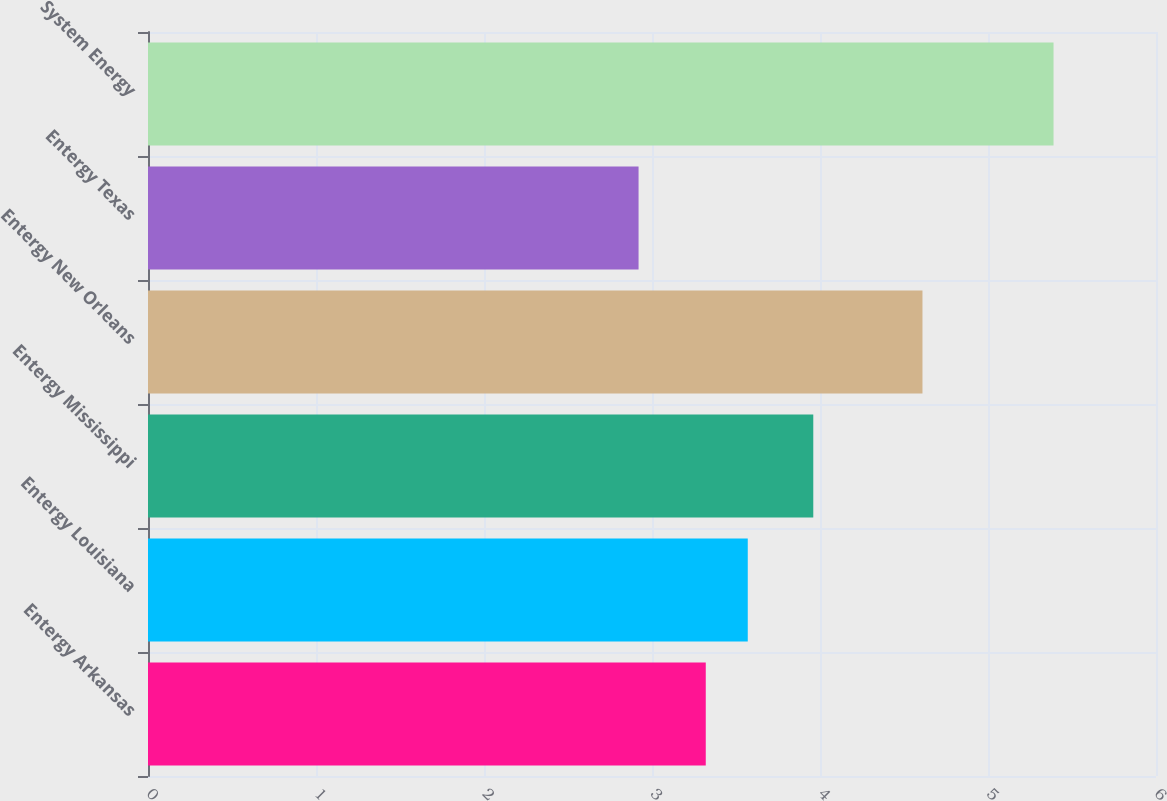Convert chart. <chart><loc_0><loc_0><loc_500><loc_500><bar_chart><fcel>Entergy Arkansas<fcel>Entergy Louisiana<fcel>Entergy Mississippi<fcel>Entergy New Orleans<fcel>Entergy Texas<fcel>System Energy<nl><fcel>3.32<fcel>3.57<fcel>3.96<fcel>4.61<fcel>2.92<fcel>5.39<nl></chart> 